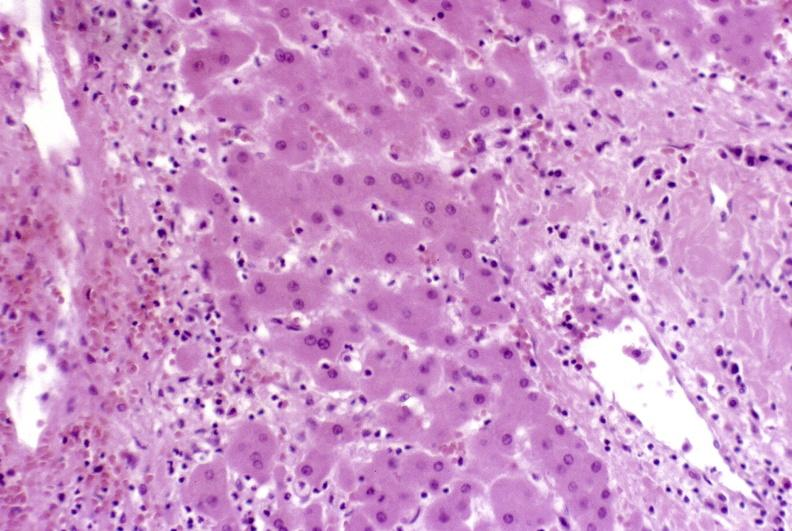what does this image show?
Answer the question using a single word or phrase. Severe acute rejection 